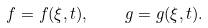<formula> <loc_0><loc_0><loc_500><loc_500>f = f ( \xi , t ) , \quad g = g ( \xi , t ) .</formula> 